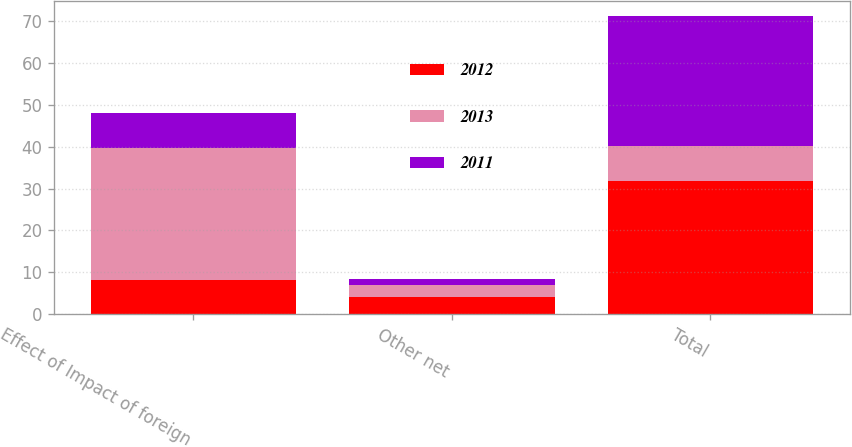Convert chart. <chart><loc_0><loc_0><loc_500><loc_500><stacked_bar_chart><ecel><fcel>Effect of Impact of foreign<fcel>Other net<fcel>Total<nl><fcel>2012<fcel>8.1<fcel>4<fcel>31.8<nl><fcel>2013<fcel>31.5<fcel>3<fcel>8.25<nl><fcel>2011<fcel>8.4<fcel>1.4<fcel>31.2<nl></chart> 